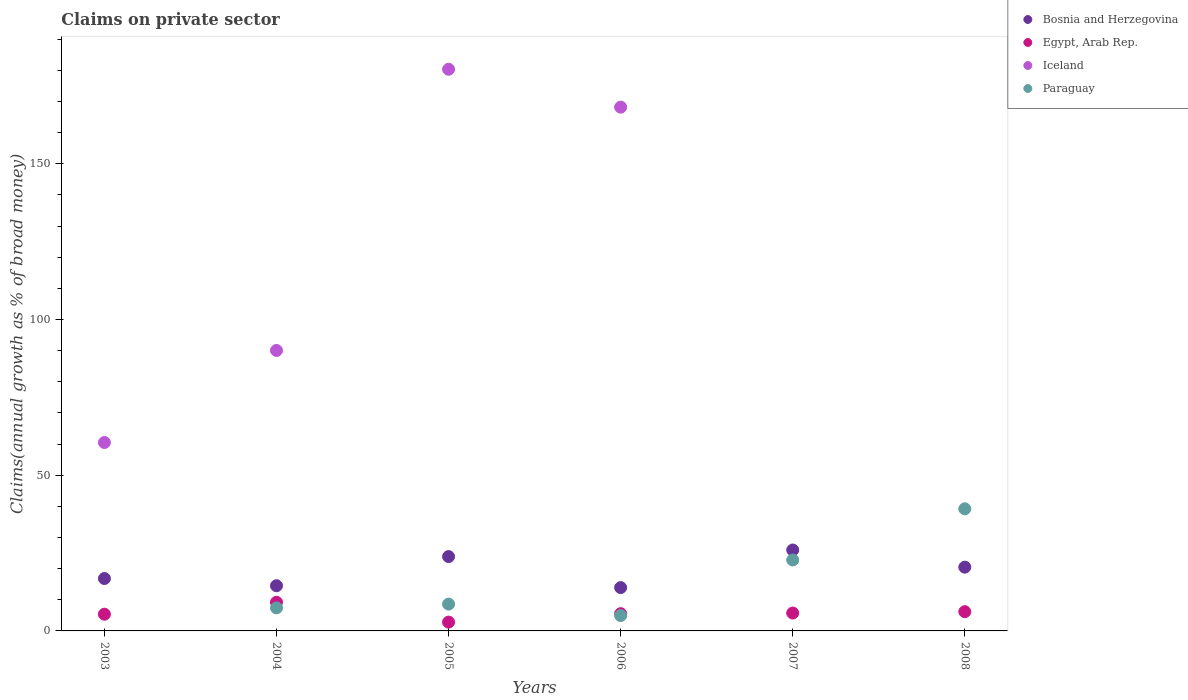Is the number of dotlines equal to the number of legend labels?
Keep it short and to the point. No. What is the percentage of broad money claimed on private sector in Iceland in 2005?
Provide a succinct answer. 180.32. Across all years, what is the maximum percentage of broad money claimed on private sector in Iceland?
Offer a very short reply. 180.32. Across all years, what is the minimum percentage of broad money claimed on private sector in Bosnia and Herzegovina?
Provide a succinct answer. 13.91. What is the total percentage of broad money claimed on private sector in Egypt, Arab Rep. in the graph?
Provide a succinct answer. 34.85. What is the difference between the percentage of broad money claimed on private sector in Paraguay in 2005 and that in 2008?
Offer a terse response. -30.59. What is the difference between the percentage of broad money claimed on private sector in Paraguay in 2006 and the percentage of broad money claimed on private sector in Bosnia and Herzegovina in 2007?
Keep it short and to the point. -21.04. What is the average percentage of broad money claimed on private sector in Iceland per year?
Provide a succinct answer. 83.17. In the year 2004, what is the difference between the percentage of broad money claimed on private sector in Egypt, Arab Rep. and percentage of broad money claimed on private sector in Paraguay?
Make the answer very short. 1.8. What is the ratio of the percentage of broad money claimed on private sector in Bosnia and Herzegovina in 2007 to that in 2008?
Keep it short and to the point. 1.27. Is the percentage of broad money claimed on private sector in Bosnia and Herzegovina in 2003 less than that in 2004?
Provide a short and direct response. No. Is the difference between the percentage of broad money claimed on private sector in Egypt, Arab Rep. in 2006 and 2008 greater than the difference between the percentage of broad money claimed on private sector in Paraguay in 2006 and 2008?
Your answer should be very brief. Yes. What is the difference between the highest and the second highest percentage of broad money claimed on private sector in Iceland?
Provide a short and direct response. 12.16. What is the difference between the highest and the lowest percentage of broad money claimed on private sector in Iceland?
Ensure brevity in your answer.  180.32. Does the percentage of broad money claimed on private sector in Bosnia and Herzegovina monotonically increase over the years?
Your answer should be very brief. No. Is the percentage of broad money claimed on private sector in Iceland strictly less than the percentage of broad money claimed on private sector in Paraguay over the years?
Keep it short and to the point. No. How many dotlines are there?
Your answer should be compact. 4. What is the difference between two consecutive major ticks on the Y-axis?
Provide a short and direct response. 50. Does the graph contain grids?
Provide a short and direct response. No. How many legend labels are there?
Make the answer very short. 4. What is the title of the graph?
Give a very brief answer. Claims on private sector. Does "Caribbean small states" appear as one of the legend labels in the graph?
Provide a succinct answer. No. What is the label or title of the Y-axis?
Your answer should be compact. Claims(annual growth as % of broad money). What is the Claims(annual growth as % of broad money) of Bosnia and Herzegovina in 2003?
Offer a very short reply. 16.82. What is the Claims(annual growth as % of broad money) in Egypt, Arab Rep. in 2003?
Offer a very short reply. 5.36. What is the Claims(annual growth as % of broad money) of Iceland in 2003?
Your answer should be compact. 60.49. What is the Claims(annual growth as % of broad money) of Paraguay in 2003?
Keep it short and to the point. 0. What is the Claims(annual growth as % of broad money) in Bosnia and Herzegovina in 2004?
Your response must be concise. 14.5. What is the Claims(annual growth as % of broad money) in Egypt, Arab Rep. in 2004?
Make the answer very short. 9.2. What is the Claims(annual growth as % of broad money) of Iceland in 2004?
Make the answer very short. 90.05. What is the Claims(annual growth as % of broad money) of Paraguay in 2004?
Your response must be concise. 7.4. What is the Claims(annual growth as % of broad money) in Bosnia and Herzegovina in 2005?
Ensure brevity in your answer.  23.87. What is the Claims(annual growth as % of broad money) in Egypt, Arab Rep. in 2005?
Your answer should be compact. 2.83. What is the Claims(annual growth as % of broad money) of Iceland in 2005?
Your response must be concise. 180.32. What is the Claims(annual growth as % of broad money) of Paraguay in 2005?
Your answer should be very brief. 8.62. What is the Claims(annual growth as % of broad money) in Bosnia and Herzegovina in 2006?
Ensure brevity in your answer.  13.91. What is the Claims(annual growth as % of broad money) of Egypt, Arab Rep. in 2006?
Keep it short and to the point. 5.54. What is the Claims(annual growth as % of broad money) in Iceland in 2006?
Provide a succinct answer. 168.16. What is the Claims(annual growth as % of broad money) of Paraguay in 2006?
Ensure brevity in your answer.  4.93. What is the Claims(annual growth as % of broad money) of Bosnia and Herzegovina in 2007?
Your answer should be very brief. 25.98. What is the Claims(annual growth as % of broad money) of Egypt, Arab Rep. in 2007?
Offer a terse response. 5.74. What is the Claims(annual growth as % of broad money) in Iceland in 2007?
Provide a succinct answer. 0. What is the Claims(annual growth as % of broad money) of Paraguay in 2007?
Your answer should be very brief. 22.78. What is the Claims(annual growth as % of broad money) in Bosnia and Herzegovina in 2008?
Offer a terse response. 20.47. What is the Claims(annual growth as % of broad money) of Egypt, Arab Rep. in 2008?
Your answer should be compact. 6.18. What is the Claims(annual growth as % of broad money) of Paraguay in 2008?
Your response must be concise. 39.21. Across all years, what is the maximum Claims(annual growth as % of broad money) of Bosnia and Herzegovina?
Your response must be concise. 25.98. Across all years, what is the maximum Claims(annual growth as % of broad money) of Egypt, Arab Rep.?
Your response must be concise. 9.2. Across all years, what is the maximum Claims(annual growth as % of broad money) of Iceland?
Your answer should be compact. 180.32. Across all years, what is the maximum Claims(annual growth as % of broad money) of Paraguay?
Your answer should be compact. 39.21. Across all years, what is the minimum Claims(annual growth as % of broad money) of Bosnia and Herzegovina?
Provide a short and direct response. 13.91. Across all years, what is the minimum Claims(annual growth as % of broad money) in Egypt, Arab Rep.?
Keep it short and to the point. 2.83. Across all years, what is the minimum Claims(annual growth as % of broad money) in Paraguay?
Offer a very short reply. 0. What is the total Claims(annual growth as % of broad money) of Bosnia and Herzegovina in the graph?
Your answer should be compact. 115.55. What is the total Claims(annual growth as % of broad money) in Egypt, Arab Rep. in the graph?
Keep it short and to the point. 34.85. What is the total Claims(annual growth as % of broad money) of Iceland in the graph?
Provide a short and direct response. 499.02. What is the total Claims(annual growth as % of broad money) of Paraguay in the graph?
Your response must be concise. 82.93. What is the difference between the Claims(annual growth as % of broad money) of Bosnia and Herzegovina in 2003 and that in 2004?
Offer a very short reply. 2.32. What is the difference between the Claims(annual growth as % of broad money) in Egypt, Arab Rep. in 2003 and that in 2004?
Offer a very short reply. -3.84. What is the difference between the Claims(annual growth as % of broad money) of Iceland in 2003 and that in 2004?
Your answer should be very brief. -29.56. What is the difference between the Claims(annual growth as % of broad money) in Bosnia and Herzegovina in 2003 and that in 2005?
Give a very brief answer. -7.05. What is the difference between the Claims(annual growth as % of broad money) in Egypt, Arab Rep. in 2003 and that in 2005?
Your response must be concise. 2.54. What is the difference between the Claims(annual growth as % of broad money) in Iceland in 2003 and that in 2005?
Offer a very short reply. -119.83. What is the difference between the Claims(annual growth as % of broad money) of Bosnia and Herzegovina in 2003 and that in 2006?
Your answer should be very brief. 2.91. What is the difference between the Claims(annual growth as % of broad money) of Egypt, Arab Rep. in 2003 and that in 2006?
Keep it short and to the point. -0.17. What is the difference between the Claims(annual growth as % of broad money) in Iceland in 2003 and that in 2006?
Provide a short and direct response. -107.67. What is the difference between the Claims(annual growth as % of broad money) in Bosnia and Herzegovina in 2003 and that in 2007?
Ensure brevity in your answer.  -9.15. What is the difference between the Claims(annual growth as % of broad money) in Egypt, Arab Rep. in 2003 and that in 2007?
Offer a very short reply. -0.38. What is the difference between the Claims(annual growth as % of broad money) in Bosnia and Herzegovina in 2003 and that in 2008?
Offer a terse response. -3.65. What is the difference between the Claims(annual growth as % of broad money) of Egypt, Arab Rep. in 2003 and that in 2008?
Give a very brief answer. -0.82. What is the difference between the Claims(annual growth as % of broad money) of Bosnia and Herzegovina in 2004 and that in 2005?
Offer a terse response. -9.36. What is the difference between the Claims(annual growth as % of broad money) in Egypt, Arab Rep. in 2004 and that in 2005?
Your answer should be very brief. 6.37. What is the difference between the Claims(annual growth as % of broad money) of Iceland in 2004 and that in 2005?
Keep it short and to the point. -90.27. What is the difference between the Claims(annual growth as % of broad money) in Paraguay in 2004 and that in 2005?
Your answer should be very brief. -1.22. What is the difference between the Claims(annual growth as % of broad money) of Bosnia and Herzegovina in 2004 and that in 2006?
Provide a short and direct response. 0.59. What is the difference between the Claims(annual growth as % of broad money) of Egypt, Arab Rep. in 2004 and that in 2006?
Keep it short and to the point. 3.66. What is the difference between the Claims(annual growth as % of broad money) of Iceland in 2004 and that in 2006?
Ensure brevity in your answer.  -78.11. What is the difference between the Claims(annual growth as % of broad money) of Paraguay in 2004 and that in 2006?
Ensure brevity in your answer.  2.46. What is the difference between the Claims(annual growth as % of broad money) of Bosnia and Herzegovina in 2004 and that in 2007?
Offer a very short reply. -11.47. What is the difference between the Claims(annual growth as % of broad money) of Egypt, Arab Rep. in 2004 and that in 2007?
Provide a succinct answer. 3.46. What is the difference between the Claims(annual growth as % of broad money) in Paraguay in 2004 and that in 2007?
Your response must be concise. -15.38. What is the difference between the Claims(annual growth as % of broad money) of Bosnia and Herzegovina in 2004 and that in 2008?
Provide a short and direct response. -5.96. What is the difference between the Claims(annual growth as % of broad money) of Egypt, Arab Rep. in 2004 and that in 2008?
Keep it short and to the point. 3.02. What is the difference between the Claims(annual growth as % of broad money) of Paraguay in 2004 and that in 2008?
Your answer should be very brief. -31.81. What is the difference between the Claims(annual growth as % of broad money) in Bosnia and Herzegovina in 2005 and that in 2006?
Your answer should be compact. 9.96. What is the difference between the Claims(annual growth as % of broad money) in Egypt, Arab Rep. in 2005 and that in 2006?
Make the answer very short. -2.71. What is the difference between the Claims(annual growth as % of broad money) of Iceland in 2005 and that in 2006?
Your answer should be compact. 12.16. What is the difference between the Claims(annual growth as % of broad money) in Paraguay in 2005 and that in 2006?
Offer a terse response. 3.68. What is the difference between the Claims(annual growth as % of broad money) of Bosnia and Herzegovina in 2005 and that in 2007?
Provide a short and direct response. -2.11. What is the difference between the Claims(annual growth as % of broad money) in Egypt, Arab Rep. in 2005 and that in 2007?
Ensure brevity in your answer.  -2.92. What is the difference between the Claims(annual growth as % of broad money) of Paraguay in 2005 and that in 2007?
Keep it short and to the point. -14.16. What is the difference between the Claims(annual growth as % of broad money) of Bosnia and Herzegovina in 2005 and that in 2008?
Ensure brevity in your answer.  3.4. What is the difference between the Claims(annual growth as % of broad money) in Egypt, Arab Rep. in 2005 and that in 2008?
Keep it short and to the point. -3.35. What is the difference between the Claims(annual growth as % of broad money) in Paraguay in 2005 and that in 2008?
Keep it short and to the point. -30.59. What is the difference between the Claims(annual growth as % of broad money) of Bosnia and Herzegovina in 2006 and that in 2007?
Make the answer very short. -12.06. What is the difference between the Claims(annual growth as % of broad money) in Egypt, Arab Rep. in 2006 and that in 2007?
Offer a terse response. -0.21. What is the difference between the Claims(annual growth as % of broad money) in Paraguay in 2006 and that in 2007?
Keep it short and to the point. -17.84. What is the difference between the Claims(annual growth as % of broad money) in Bosnia and Herzegovina in 2006 and that in 2008?
Offer a terse response. -6.56. What is the difference between the Claims(annual growth as % of broad money) in Egypt, Arab Rep. in 2006 and that in 2008?
Your response must be concise. -0.64. What is the difference between the Claims(annual growth as % of broad money) of Paraguay in 2006 and that in 2008?
Provide a succinct answer. -34.28. What is the difference between the Claims(annual growth as % of broad money) of Bosnia and Herzegovina in 2007 and that in 2008?
Your response must be concise. 5.51. What is the difference between the Claims(annual growth as % of broad money) of Egypt, Arab Rep. in 2007 and that in 2008?
Ensure brevity in your answer.  -0.44. What is the difference between the Claims(annual growth as % of broad money) of Paraguay in 2007 and that in 2008?
Give a very brief answer. -16.43. What is the difference between the Claims(annual growth as % of broad money) of Bosnia and Herzegovina in 2003 and the Claims(annual growth as % of broad money) of Egypt, Arab Rep. in 2004?
Offer a very short reply. 7.62. What is the difference between the Claims(annual growth as % of broad money) in Bosnia and Herzegovina in 2003 and the Claims(annual growth as % of broad money) in Iceland in 2004?
Keep it short and to the point. -73.23. What is the difference between the Claims(annual growth as % of broad money) of Bosnia and Herzegovina in 2003 and the Claims(annual growth as % of broad money) of Paraguay in 2004?
Offer a very short reply. 9.42. What is the difference between the Claims(annual growth as % of broad money) in Egypt, Arab Rep. in 2003 and the Claims(annual growth as % of broad money) in Iceland in 2004?
Your answer should be compact. -84.69. What is the difference between the Claims(annual growth as % of broad money) in Egypt, Arab Rep. in 2003 and the Claims(annual growth as % of broad money) in Paraguay in 2004?
Your response must be concise. -2.03. What is the difference between the Claims(annual growth as % of broad money) of Iceland in 2003 and the Claims(annual growth as % of broad money) of Paraguay in 2004?
Your answer should be very brief. 53.09. What is the difference between the Claims(annual growth as % of broad money) in Bosnia and Herzegovina in 2003 and the Claims(annual growth as % of broad money) in Egypt, Arab Rep. in 2005?
Your answer should be compact. 14. What is the difference between the Claims(annual growth as % of broad money) in Bosnia and Herzegovina in 2003 and the Claims(annual growth as % of broad money) in Iceland in 2005?
Provide a succinct answer. -163.5. What is the difference between the Claims(annual growth as % of broad money) in Bosnia and Herzegovina in 2003 and the Claims(annual growth as % of broad money) in Paraguay in 2005?
Your response must be concise. 8.21. What is the difference between the Claims(annual growth as % of broad money) of Egypt, Arab Rep. in 2003 and the Claims(annual growth as % of broad money) of Iceland in 2005?
Your answer should be very brief. -174.96. What is the difference between the Claims(annual growth as % of broad money) of Egypt, Arab Rep. in 2003 and the Claims(annual growth as % of broad money) of Paraguay in 2005?
Provide a short and direct response. -3.25. What is the difference between the Claims(annual growth as % of broad money) in Iceland in 2003 and the Claims(annual growth as % of broad money) in Paraguay in 2005?
Make the answer very short. 51.87. What is the difference between the Claims(annual growth as % of broad money) of Bosnia and Herzegovina in 2003 and the Claims(annual growth as % of broad money) of Egypt, Arab Rep. in 2006?
Provide a succinct answer. 11.29. What is the difference between the Claims(annual growth as % of broad money) in Bosnia and Herzegovina in 2003 and the Claims(annual growth as % of broad money) in Iceland in 2006?
Your answer should be very brief. -151.34. What is the difference between the Claims(annual growth as % of broad money) of Bosnia and Herzegovina in 2003 and the Claims(annual growth as % of broad money) of Paraguay in 2006?
Your response must be concise. 11.89. What is the difference between the Claims(annual growth as % of broad money) of Egypt, Arab Rep. in 2003 and the Claims(annual growth as % of broad money) of Iceland in 2006?
Ensure brevity in your answer.  -162.8. What is the difference between the Claims(annual growth as % of broad money) of Egypt, Arab Rep. in 2003 and the Claims(annual growth as % of broad money) of Paraguay in 2006?
Your response must be concise. 0.43. What is the difference between the Claims(annual growth as % of broad money) of Iceland in 2003 and the Claims(annual growth as % of broad money) of Paraguay in 2006?
Ensure brevity in your answer.  55.56. What is the difference between the Claims(annual growth as % of broad money) in Bosnia and Herzegovina in 2003 and the Claims(annual growth as % of broad money) in Egypt, Arab Rep. in 2007?
Provide a short and direct response. 11.08. What is the difference between the Claims(annual growth as % of broad money) of Bosnia and Herzegovina in 2003 and the Claims(annual growth as % of broad money) of Paraguay in 2007?
Make the answer very short. -5.95. What is the difference between the Claims(annual growth as % of broad money) of Egypt, Arab Rep. in 2003 and the Claims(annual growth as % of broad money) of Paraguay in 2007?
Offer a very short reply. -17.41. What is the difference between the Claims(annual growth as % of broad money) in Iceland in 2003 and the Claims(annual growth as % of broad money) in Paraguay in 2007?
Keep it short and to the point. 37.71. What is the difference between the Claims(annual growth as % of broad money) in Bosnia and Herzegovina in 2003 and the Claims(annual growth as % of broad money) in Egypt, Arab Rep. in 2008?
Provide a short and direct response. 10.64. What is the difference between the Claims(annual growth as % of broad money) in Bosnia and Herzegovina in 2003 and the Claims(annual growth as % of broad money) in Paraguay in 2008?
Your answer should be compact. -22.39. What is the difference between the Claims(annual growth as % of broad money) in Egypt, Arab Rep. in 2003 and the Claims(annual growth as % of broad money) in Paraguay in 2008?
Provide a short and direct response. -33.85. What is the difference between the Claims(annual growth as % of broad money) of Iceland in 2003 and the Claims(annual growth as % of broad money) of Paraguay in 2008?
Ensure brevity in your answer.  21.28. What is the difference between the Claims(annual growth as % of broad money) of Bosnia and Herzegovina in 2004 and the Claims(annual growth as % of broad money) of Egypt, Arab Rep. in 2005?
Provide a succinct answer. 11.68. What is the difference between the Claims(annual growth as % of broad money) of Bosnia and Herzegovina in 2004 and the Claims(annual growth as % of broad money) of Iceland in 2005?
Keep it short and to the point. -165.82. What is the difference between the Claims(annual growth as % of broad money) in Bosnia and Herzegovina in 2004 and the Claims(annual growth as % of broad money) in Paraguay in 2005?
Your answer should be very brief. 5.89. What is the difference between the Claims(annual growth as % of broad money) in Egypt, Arab Rep. in 2004 and the Claims(annual growth as % of broad money) in Iceland in 2005?
Offer a very short reply. -171.12. What is the difference between the Claims(annual growth as % of broad money) of Egypt, Arab Rep. in 2004 and the Claims(annual growth as % of broad money) of Paraguay in 2005?
Make the answer very short. 0.58. What is the difference between the Claims(annual growth as % of broad money) in Iceland in 2004 and the Claims(annual growth as % of broad money) in Paraguay in 2005?
Your answer should be compact. 81.43. What is the difference between the Claims(annual growth as % of broad money) of Bosnia and Herzegovina in 2004 and the Claims(annual growth as % of broad money) of Egypt, Arab Rep. in 2006?
Make the answer very short. 8.97. What is the difference between the Claims(annual growth as % of broad money) of Bosnia and Herzegovina in 2004 and the Claims(annual growth as % of broad money) of Iceland in 2006?
Make the answer very short. -153.66. What is the difference between the Claims(annual growth as % of broad money) in Bosnia and Herzegovina in 2004 and the Claims(annual growth as % of broad money) in Paraguay in 2006?
Your answer should be very brief. 9.57. What is the difference between the Claims(annual growth as % of broad money) of Egypt, Arab Rep. in 2004 and the Claims(annual growth as % of broad money) of Iceland in 2006?
Your answer should be compact. -158.96. What is the difference between the Claims(annual growth as % of broad money) of Egypt, Arab Rep. in 2004 and the Claims(annual growth as % of broad money) of Paraguay in 2006?
Offer a very short reply. 4.27. What is the difference between the Claims(annual growth as % of broad money) of Iceland in 2004 and the Claims(annual growth as % of broad money) of Paraguay in 2006?
Ensure brevity in your answer.  85.12. What is the difference between the Claims(annual growth as % of broad money) in Bosnia and Herzegovina in 2004 and the Claims(annual growth as % of broad money) in Egypt, Arab Rep. in 2007?
Provide a succinct answer. 8.76. What is the difference between the Claims(annual growth as % of broad money) of Bosnia and Herzegovina in 2004 and the Claims(annual growth as % of broad money) of Paraguay in 2007?
Give a very brief answer. -8.27. What is the difference between the Claims(annual growth as % of broad money) of Egypt, Arab Rep. in 2004 and the Claims(annual growth as % of broad money) of Paraguay in 2007?
Your answer should be very brief. -13.58. What is the difference between the Claims(annual growth as % of broad money) of Iceland in 2004 and the Claims(annual growth as % of broad money) of Paraguay in 2007?
Offer a very short reply. 67.27. What is the difference between the Claims(annual growth as % of broad money) in Bosnia and Herzegovina in 2004 and the Claims(annual growth as % of broad money) in Egypt, Arab Rep. in 2008?
Give a very brief answer. 8.33. What is the difference between the Claims(annual growth as % of broad money) of Bosnia and Herzegovina in 2004 and the Claims(annual growth as % of broad money) of Paraguay in 2008?
Keep it short and to the point. -24.7. What is the difference between the Claims(annual growth as % of broad money) in Egypt, Arab Rep. in 2004 and the Claims(annual growth as % of broad money) in Paraguay in 2008?
Ensure brevity in your answer.  -30.01. What is the difference between the Claims(annual growth as % of broad money) of Iceland in 2004 and the Claims(annual growth as % of broad money) of Paraguay in 2008?
Give a very brief answer. 50.84. What is the difference between the Claims(annual growth as % of broad money) of Bosnia and Herzegovina in 2005 and the Claims(annual growth as % of broad money) of Egypt, Arab Rep. in 2006?
Offer a terse response. 18.33. What is the difference between the Claims(annual growth as % of broad money) in Bosnia and Herzegovina in 2005 and the Claims(annual growth as % of broad money) in Iceland in 2006?
Provide a succinct answer. -144.29. What is the difference between the Claims(annual growth as % of broad money) of Bosnia and Herzegovina in 2005 and the Claims(annual growth as % of broad money) of Paraguay in 2006?
Your answer should be compact. 18.93. What is the difference between the Claims(annual growth as % of broad money) of Egypt, Arab Rep. in 2005 and the Claims(annual growth as % of broad money) of Iceland in 2006?
Ensure brevity in your answer.  -165.33. What is the difference between the Claims(annual growth as % of broad money) in Egypt, Arab Rep. in 2005 and the Claims(annual growth as % of broad money) in Paraguay in 2006?
Offer a very short reply. -2.11. What is the difference between the Claims(annual growth as % of broad money) in Iceland in 2005 and the Claims(annual growth as % of broad money) in Paraguay in 2006?
Ensure brevity in your answer.  175.39. What is the difference between the Claims(annual growth as % of broad money) of Bosnia and Herzegovina in 2005 and the Claims(annual growth as % of broad money) of Egypt, Arab Rep. in 2007?
Offer a very short reply. 18.13. What is the difference between the Claims(annual growth as % of broad money) in Bosnia and Herzegovina in 2005 and the Claims(annual growth as % of broad money) in Paraguay in 2007?
Offer a terse response. 1.09. What is the difference between the Claims(annual growth as % of broad money) of Egypt, Arab Rep. in 2005 and the Claims(annual growth as % of broad money) of Paraguay in 2007?
Provide a succinct answer. -19.95. What is the difference between the Claims(annual growth as % of broad money) in Iceland in 2005 and the Claims(annual growth as % of broad money) in Paraguay in 2007?
Keep it short and to the point. 157.54. What is the difference between the Claims(annual growth as % of broad money) of Bosnia and Herzegovina in 2005 and the Claims(annual growth as % of broad money) of Egypt, Arab Rep. in 2008?
Your response must be concise. 17.69. What is the difference between the Claims(annual growth as % of broad money) in Bosnia and Herzegovina in 2005 and the Claims(annual growth as % of broad money) in Paraguay in 2008?
Provide a succinct answer. -15.34. What is the difference between the Claims(annual growth as % of broad money) of Egypt, Arab Rep. in 2005 and the Claims(annual growth as % of broad money) of Paraguay in 2008?
Offer a terse response. -36.38. What is the difference between the Claims(annual growth as % of broad money) of Iceland in 2005 and the Claims(annual growth as % of broad money) of Paraguay in 2008?
Ensure brevity in your answer.  141.11. What is the difference between the Claims(annual growth as % of broad money) of Bosnia and Herzegovina in 2006 and the Claims(annual growth as % of broad money) of Egypt, Arab Rep. in 2007?
Give a very brief answer. 8.17. What is the difference between the Claims(annual growth as % of broad money) in Bosnia and Herzegovina in 2006 and the Claims(annual growth as % of broad money) in Paraguay in 2007?
Provide a succinct answer. -8.87. What is the difference between the Claims(annual growth as % of broad money) in Egypt, Arab Rep. in 2006 and the Claims(annual growth as % of broad money) in Paraguay in 2007?
Keep it short and to the point. -17.24. What is the difference between the Claims(annual growth as % of broad money) of Iceland in 2006 and the Claims(annual growth as % of broad money) of Paraguay in 2007?
Keep it short and to the point. 145.38. What is the difference between the Claims(annual growth as % of broad money) in Bosnia and Herzegovina in 2006 and the Claims(annual growth as % of broad money) in Egypt, Arab Rep. in 2008?
Keep it short and to the point. 7.73. What is the difference between the Claims(annual growth as % of broad money) in Bosnia and Herzegovina in 2006 and the Claims(annual growth as % of broad money) in Paraguay in 2008?
Give a very brief answer. -25.3. What is the difference between the Claims(annual growth as % of broad money) in Egypt, Arab Rep. in 2006 and the Claims(annual growth as % of broad money) in Paraguay in 2008?
Offer a very short reply. -33.67. What is the difference between the Claims(annual growth as % of broad money) in Iceland in 2006 and the Claims(annual growth as % of broad money) in Paraguay in 2008?
Your response must be concise. 128.95. What is the difference between the Claims(annual growth as % of broad money) of Bosnia and Herzegovina in 2007 and the Claims(annual growth as % of broad money) of Egypt, Arab Rep. in 2008?
Provide a short and direct response. 19.8. What is the difference between the Claims(annual growth as % of broad money) in Bosnia and Herzegovina in 2007 and the Claims(annual growth as % of broad money) in Paraguay in 2008?
Give a very brief answer. -13.23. What is the difference between the Claims(annual growth as % of broad money) of Egypt, Arab Rep. in 2007 and the Claims(annual growth as % of broad money) of Paraguay in 2008?
Your answer should be compact. -33.47. What is the average Claims(annual growth as % of broad money) in Bosnia and Herzegovina per year?
Your response must be concise. 19.26. What is the average Claims(annual growth as % of broad money) in Egypt, Arab Rep. per year?
Provide a succinct answer. 5.81. What is the average Claims(annual growth as % of broad money) of Iceland per year?
Keep it short and to the point. 83.17. What is the average Claims(annual growth as % of broad money) in Paraguay per year?
Keep it short and to the point. 13.82. In the year 2003, what is the difference between the Claims(annual growth as % of broad money) in Bosnia and Herzegovina and Claims(annual growth as % of broad money) in Egypt, Arab Rep.?
Offer a terse response. 11.46. In the year 2003, what is the difference between the Claims(annual growth as % of broad money) of Bosnia and Herzegovina and Claims(annual growth as % of broad money) of Iceland?
Keep it short and to the point. -43.67. In the year 2003, what is the difference between the Claims(annual growth as % of broad money) in Egypt, Arab Rep. and Claims(annual growth as % of broad money) in Iceland?
Your response must be concise. -55.13. In the year 2004, what is the difference between the Claims(annual growth as % of broad money) in Bosnia and Herzegovina and Claims(annual growth as % of broad money) in Egypt, Arab Rep.?
Make the answer very short. 5.3. In the year 2004, what is the difference between the Claims(annual growth as % of broad money) in Bosnia and Herzegovina and Claims(annual growth as % of broad money) in Iceland?
Your response must be concise. -75.55. In the year 2004, what is the difference between the Claims(annual growth as % of broad money) in Bosnia and Herzegovina and Claims(annual growth as % of broad money) in Paraguay?
Make the answer very short. 7.11. In the year 2004, what is the difference between the Claims(annual growth as % of broad money) in Egypt, Arab Rep. and Claims(annual growth as % of broad money) in Iceland?
Provide a short and direct response. -80.85. In the year 2004, what is the difference between the Claims(annual growth as % of broad money) in Egypt, Arab Rep. and Claims(annual growth as % of broad money) in Paraguay?
Provide a short and direct response. 1.8. In the year 2004, what is the difference between the Claims(annual growth as % of broad money) in Iceland and Claims(annual growth as % of broad money) in Paraguay?
Provide a succinct answer. 82.65. In the year 2005, what is the difference between the Claims(annual growth as % of broad money) in Bosnia and Herzegovina and Claims(annual growth as % of broad money) in Egypt, Arab Rep.?
Offer a terse response. 21.04. In the year 2005, what is the difference between the Claims(annual growth as % of broad money) of Bosnia and Herzegovina and Claims(annual growth as % of broad money) of Iceland?
Keep it short and to the point. -156.45. In the year 2005, what is the difference between the Claims(annual growth as % of broad money) of Bosnia and Herzegovina and Claims(annual growth as % of broad money) of Paraguay?
Ensure brevity in your answer.  15.25. In the year 2005, what is the difference between the Claims(annual growth as % of broad money) of Egypt, Arab Rep. and Claims(annual growth as % of broad money) of Iceland?
Your answer should be compact. -177.49. In the year 2005, what is the difference between the Claims(annual growth as % of broad money) of Egypt, Arab Rep. and Claims(annual growth as % of broad money) of Paraguay?
Provide a short and direct response. -5.79. In the year 2005, what is the difference between the Claims(annual growth as % of broad money) in Iceland and Claims(annual growth as % of broad money) in Paraguay?
Offer a very short reply. 171.7. In the year 2006, what is the difference between the Claims(annual growth as % of broad money) in Bosnia and Herzegovina and Claims(annual growth as % of broad money) in Egypt, Arab Rep.?
Keep it short and to the point. 8.37. In the year 2006, what is the difference between the Claims(annual growth as % of broad money) in Bosnia and Herzegovina and Claims(annual growth as % of broad money) in Iceland?
Offer a terse response. -154.25. In the year 2006, what is the difference between the Claims(annual growth as % of broad money) of Bosnia and Herzegovina and Claims(annual growth as % of broad money) of Paraguay?
Your answer should be compact. 8.98. In the year 2006, what is the difference between the Claims(annual growth as % of broad money) of Egypt, Arab Rep. and Claims(annual growth as % of broad money) of Iceland?
Your response must be concise. -162.62. In the year 2006, what is the difference between the Claims(annual growth as % of broad money) of Egypt, Arab Rep. and Claims(annual growth as % of broad money) of Paraguay?
Provide a short and direct response. 0.6. In the year 2006, what is the difference between the Claims(annual growth as % of broad money) in Iceland and Claims(annual growth as % of broad money) in Paraguay?
Offer a very short reply. 163.23. In the year 2007, what is the difference between the Claims(annual growth as % of broad money) in Bosnia and Herzegovina and Claims(annual growth as % of broad money) in Egypt, Arab Rep.?
Keep it short and to the point. 20.23. In the year 2007, what is the difference between the Claims(annual growth as % of broad money) in Bosnia and Herzegovina and Claims(annual growth as % of broad money) in Paraguay?
Offer a very short reply. 3.2. In the year 2007, what is the difference between the Claims(annual growth as % of broad money) in Egypt, Arab Rep. and Claims(annual growth as % of broad money) in Paraguay?
Ensure brevity in your answer.  -17.03. In the year 2008, what is the difference between the Claims(annual growth as % of broad money) in Bosnia and Herzegovina and Claims(annual growth as % of broad money) in Egypt, Arab Rep.?
Make the answer very short. 14.29. In the year 2008, what is the difference between the Claims(annual growth as % of broad money) of Bosnia and Herzegovina and Claims(annual growth as % of broad money) of Paraguay?
Your answer should be very brief. -18.74. In the year 2008, what is the difference between the Claims(annual growth as % of broad money) in Egypt, Arab Rep. and Claims(annual growth as % of broad money) in Paraguay?
Provide a short and direct response. -33.03. What is the ratio of the Claims(annual growth as % of broad money) of Bosnia and Herzegovina in 2003 to that in 2004?
Ensure brevity in your answer.  1.16. What is the ratio of the Claims(annual growth as % of broad money) in Egypt, Arab Rep. in 2003 to that in 2004?
Offer a very short reply. 0.58. What is the ratio of the Claims(annual growth as % of broad money) in Iceland in 2003 to that in 2004?
Ensure brevity in your answer.  0.67. What is the ratio of the Claims(annual growth as % of broad money) in Bosnia and Herzegovina in 2003 to that in 2005?
Keep it short and to the point. 0.7. What is the ratio of the Claims(annual growth as % of broad money) of Egypt, Arab Rep. in 2003 to that in 2005?
Offer a very short reply. 1.9. What is the ratio of the Claims(annual growth as % of broad money) in Iceland in 2003 to that in 2005?
Give a very brief answer. 0.34. What is the ratio of the Claims(annual growth as % of broad money) of Bosnia and Herzegovina in 2003 to that in 2006?
Offer a terse response. 1.21. What is the ratio of the Claims(annual growth as % of broad money) of Egypt, Arab Rep. in 2003 to that in 2006?
Your response must be concise. 0.97. What is the ratio of the Claims(annual growth as % of broad money) in Iceland in 2003 to that in 2006?
Offer a very short reply. 0.36. What is the ratio of the Claims(annual growth as % of broad money) of Bosnia and Herzegovina in 2003 to that in 2007?
Give a very brief answer. 0.65. What is the ratio of the Claims(annual growth as % of broad money) in Egypt, Arab Rep. in 2003 to that in 2007?
Keep it short and to the point. 0.93. What is the ratio of the Claims(annual growth as % of broad money) of Bosnia and Herzegovina in 2003 to that in 2008?
Ensure brevity in your answer.  0.82. What is the ratio of the Claims(annual growth as % of broad money) in Egypt, Arab Rep. in 2003 to that in 2008?
Your answer should be very brief. 0.87. What is the ratio of the Claims(annual growth as % of broad money) of Bosnia and Herzegovina in 2004 to that in 2005?
Ensure brevity in your answer.  0.61. What is the ratio of the Claims(annual growth as % of broad money) in Egypt, Arab Rep. in 2004 to that in 2005?
Make the answer very short. 3.25. What is the ratio of the Claims(annual growth as % of broad money) of Iceland in 2004 to that in 2005?
Provide a succinct answer. 0.5. What is the ratio of the Claims(annual growth as % of broad money) in Paraguay in 2004 to that in 2005?
Ensure brevity in your answer.  0.86. What is the ratio of the Claims(annual growth as % of broad money) in Bosnia and Herzegovina in 2004 to that in 2006?
Give a very brief answer. 1.04. What is the ratio of the Claims(annual growth as % of broad money) of Egypt, Arab Rep. in 2004 to that in 2006?
Provide a short and direct response. 1.66. What is the ratio of the Claims(annual growth as % of broad money) in Iceland in 2004 to that in 2006?
Ensure brevity in your answer.  0.54. What is the ratio of the Claims(annual growth as % of broad money) in Paraguay in 2004 to that in 2006?
Ensure brevity in your answer.  1.5. What is the ratio of the Claims(annual growth as % of broad money) in Bosnia and Herzegovina in 2004 to that in 2007?
Give a very brief answer. 0.56. What is the ratio of the Claims(annual growth as % of broad money) in Egypt, Arab Rep. in 2004 to that in 2007?
Your answer should be compact. 1.6. What is the ratio of the Claims(annual growth as % of broad money) of Paraguay in 2004 to that in 2007?
Your answer should be very brief. 0.32. What is the ratio of the Claims(annual growth as % of broad money) in Bosnia and Herzegovina in 2004 to that in 2008?
Provide a succinct answer. 0.71. What is the ratio of the Claims(annual growth as % of broad money) in Egypt, Arab Rep. in 2004 to that in 2008?
Provide a succinct answer. 1.49. What is the ratio of the Claims(annual growth as % of broad money) in Paraguay in 2004 to that in 2008?
Provide a succinct answer. 0.19. What is the ratio of the Claims(annual growth as % of broad money) in Bosnia and Herzegovina in 2005 to that in 2006?
Ensure brevity in your answer.  1.72. What is the ratio of the Claims(annual growth as % of broad money) of Egypt, Arab Rep. in 2005 to that in 2006?
Offer a very short reply. 0.51. What is the ratio of the Claims(annual growth as % of broad money) in Iceland in 2005 to that in 2006?
Provide a short and direct response. 1.07. What is the ratio of the Claims(annual growth as % of broad money) of Paraguay in 2005 to that in 2006?
Your answer should be compact. 1.75. What is the ratio of the Claims(annual growth as % of broad money) in Bosnia and Herzegovina in 2005 to that in 2007?
Offer a terse response. 0.92. What is the ratio of the Claims(annual growth as % of broad money) of Egypt, Arab Rep. in 2005 to that in 2007?
Keep it short and to the point. 0.49. What is the ratio of the Claims(annual growth as % of broad money) in Paraguay in 2005 to that in 2007?
Offer a terse response. 0.38. What is the ratio of the Claims(annual growth as % of broad money) in Bosnia and Herzegovina in 2005 to that in 2008?
Keep it short and to the point. 1.17. What is the ratio of the Claims(annual growth as % of broad money) of Egypt, Arab Rep. in 2005 to that in 2008?
Your response must be concise. 0.46. What is the ratio of the Claims(annual growth as % of broad money) of Paraguay in 2005 to that in 2008?
Ensure brevity in your answer.  0.22. What is the ratio of the Claims(annual growth as % of broad money) of Bosnia and Herzegovina in 2006 to that in 2007?
Your answer should be compact. 0.54. What is the ratio of the Claims(annual growth as % of broad money) in Egypt, Arab Rep. in 2006 to that in 2007?
Provide a short and direct response. 0.96. What is the ratio of the Claims(annual growth as % of broad money) in Paraguay in 2006 to that in 2007?
Offer a very short reply. 0.22. What is the ratio of the Claims(annual growth as % of broad money) in Bosnia and Herzegovina in 2006 to that in 2008?
Your answer should be very brief. 0.68. What is the ratio of the Claims(annual growth as % of broad money) of Egypt, Arab Rep. in 2006 to that in 2008?
Keep it short and to the point. 0.9. What is the ratio of the Claims(annual growth as % of broad money) of Paraguay in 2006 to that in 2008?
Offer a very short reply. 0.13. What is the ratio of the Claims(annual growth as % of broad money) of Bosnia and Herzegovina in 2007 to that in 2008?
Your answer should be compact. 1.27. What is the ratio of the Claims(annual growth as % of broad money) in Egypt, Arab Rep. in 2007 to that in 2008?
Your answer should be compact. 0.93. What is the ratio of the Claims(annual growth as % of broad money) in Paraguay in 2007 to that in 2008?
Make the answer very short. 0.58. What is the difference between the highest and the second highest Claims(annual growth as % of broad money) of Bosnia and Herzegovina?
Provide a succinct answer. 2.11. What is the difference between the highest and the second highest Claims(annual growth as % of broad money) in Egypt, Arab Rep.?
Give a very brief answer. 3.02. What is the difference between the highest and the second highest Claims(annual growth as % of broad money) of Iceland?
Your response must be concise. 12.16. What is the difference between the highest and the second highest Claims(annual growth as % of broad money) of Paraguay?
Give a very brief answer. 16.43. What is the difference between the highest and the lowest Claims(annual growth as % of broad money) in Bosnia and Herzegovina?
Your answer should be very brief. 12.06. What is the difference between the highest and the lowest Claims(annual growth as % of broad money) in Egypt, Arab Rep.?
Your answer should be very brief. 6.37. What is the difference between the highest and the lowest Claims(annual growth as % of broad money) of Iceland?
Give a very brief answer. 180.32. What is the difference between the highest and the lowest Claims(annual growth as % of broad money) of Paraguay?
Ensure brevity in your answer.  39.21. 